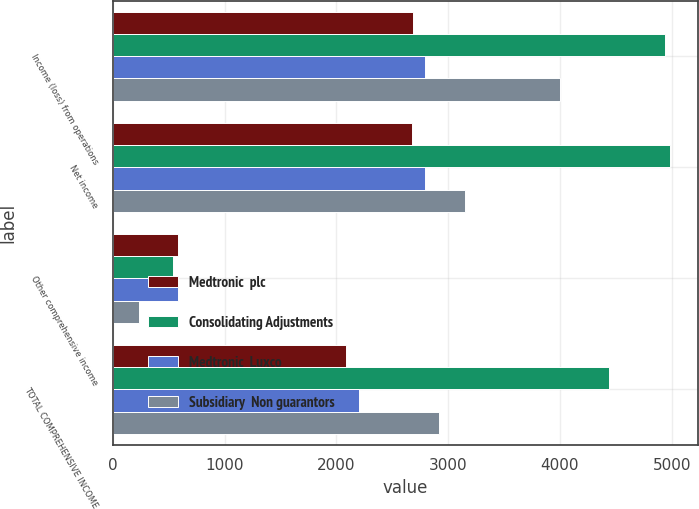Convert chart. <chart><loc_0><loc_0><loc_500><loc_500><stacked_bar_chart><ecel><fcel>Income (loss) from operations<fcel>Net income<fcel>Other comprehensive income<fcel>TOTAL COMPREHENSIVE INCOME<nl><fcel>Medtronic  plc<fcel>2686<fcel>2675<fcel>587<fcel>2088<nl><fcel>Consolidating Adjustments<fcel>4939<fcel>4983<fcel>542<fcel>4441<nl><fcel>Medtronic  Luxco<fcel>2790<fcel>2790<fcel>587<fcel>2203<nl><fcel>Subsidiary  Non guarantors<fcel>3997<fcel>3153<fcel>232<fcel>2921<nl></chart> 